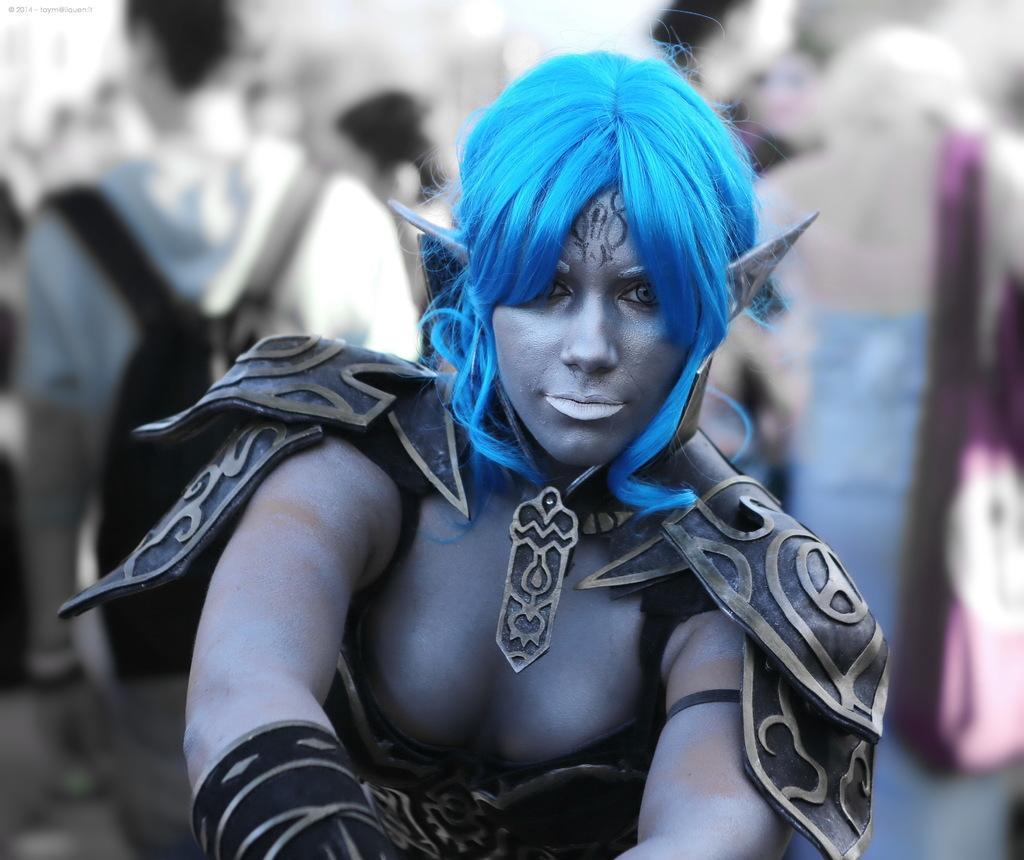Please provide a concise description of this image. This image there is a woman standing. She is wearing a costume. Behind her there are a few people standing. They are wearing bags. The background is blurry. 